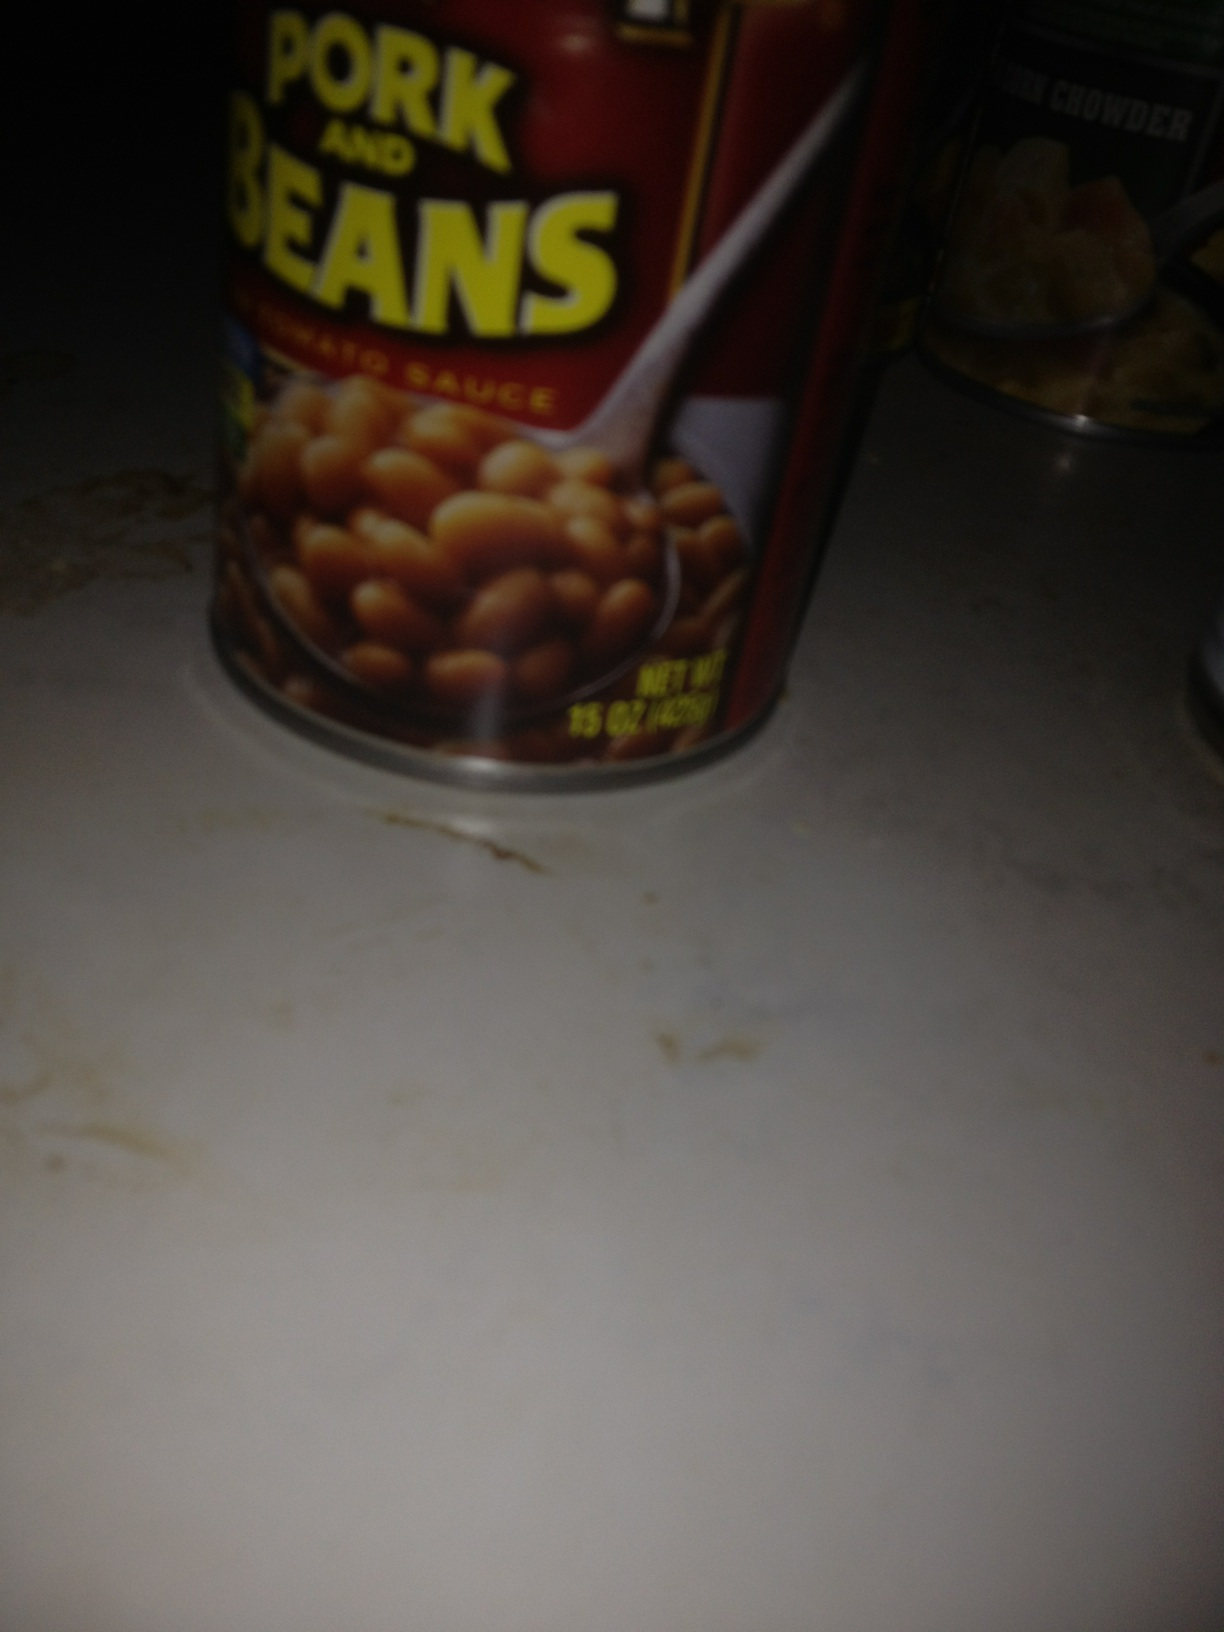Based on the image, what scenarios do you think happened right before this photo was taken? Short: Someone probably just returned from a grocery shopping trip and set these cans on the counter before deciding where to store them. The slightly haphazard arrangement suggests they might have been in a hurry. Long: Right before this photo was taken, it could be that the person was in the middle of preparing a meal and took out the cans to consider their options. They might have been deciding whether to make a hearty bowl of beans or a warming clam chowder. The countertop has some slight stains and irregularities, suggesting a busy kitchen that sees a lot of use, possibly from cooking meals for a large family or entertaining guests. The person might have been grabbing these items quickly amidst the hustle and bustle, underscoring the liveliness of the household. 